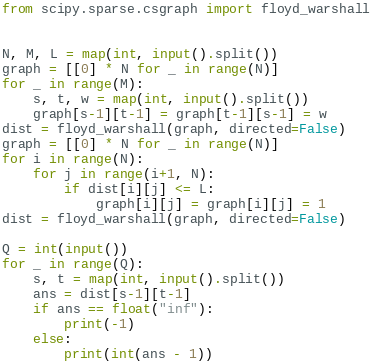<code> <loc_0><loc_0><loc_500><loc_500><_Python_>from scipy.sparse.csgraph import floyd_warshall


N, M, L = map(int, input().split())
graph = [[0] * N for _ in range(N)]
for _ in range(M):
    s, t, w = map(int, input().split())
    graph[s-1][t-1] = graph[t-1][s-1] = w
dist = floyd_warshall(graph, directed=False)
graph = [[0] * N for _ in range(N)]
for i in range(N):
    for j in range(i+1, N):
        if dist[i][j] <= L:
            graph[i][j] = graph[i][j] = 1
dist = floyd_warshall(graph, directed=False)

Q = int(input())
for _ in range(Q):
    s, t = map(int, input().split())
    ans = dist[s-1][t-1]
    if ans == float("inf"):
        print(-1)
    else:
        print(int(ans - 1))
</code> 